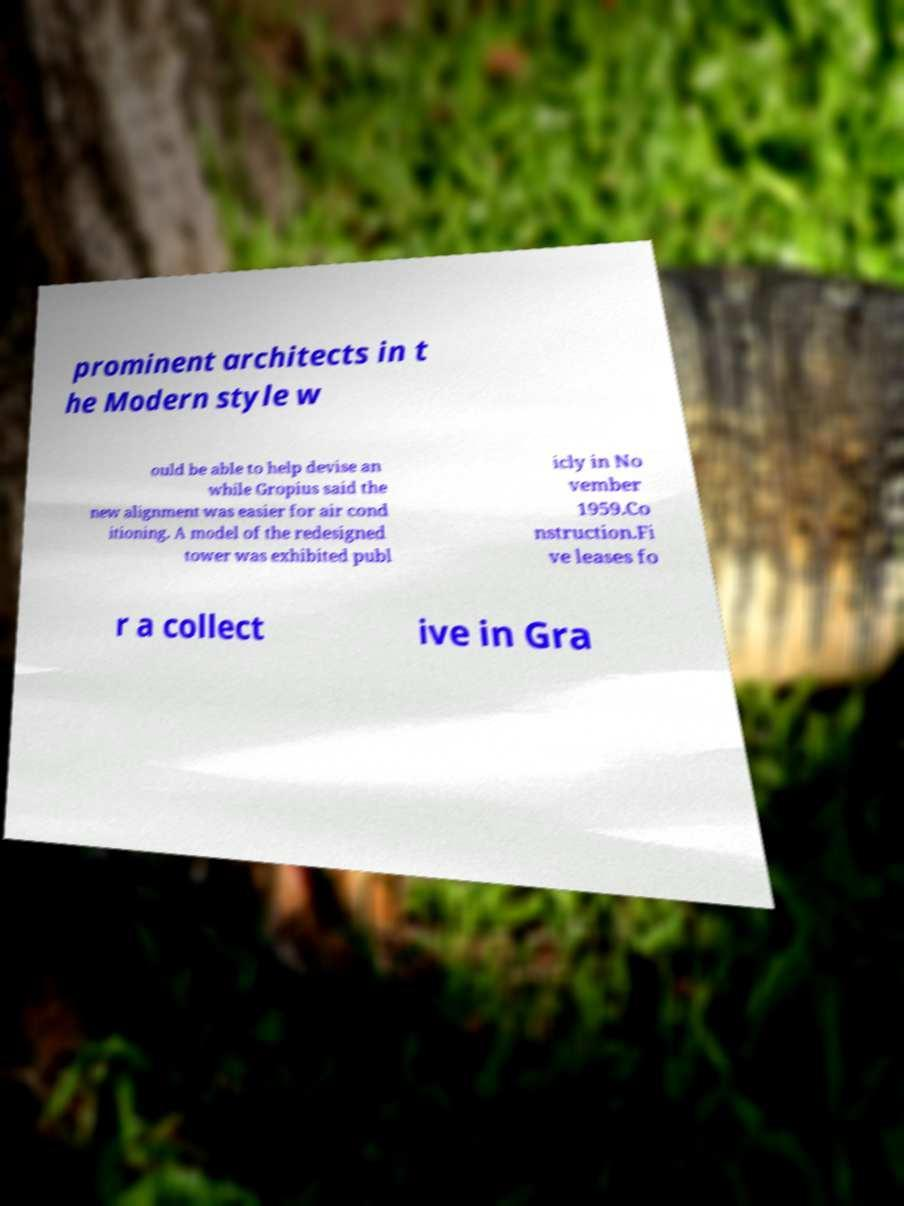Could you assist in decoding the text presented in this image and type it out clearly? prominent architects in t he Modern style w ould be able to help devise an while Gropius said the new alignment was easier for air cond itioning. A model of the redesigned tower was exhibited publ icly in No vember 1959.Co nstruction.Fi ve leases fo r a collect ive in Gra 